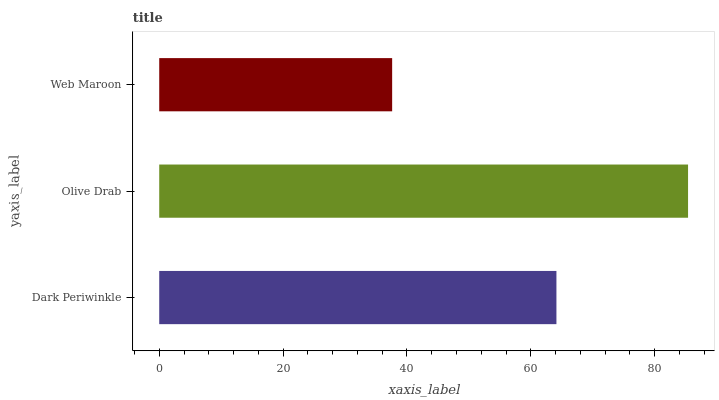Is Web Maroon the minimum?
Answer yes or no. Yes. Is Olive Drab the maximum?
Answer yes or no. Yes. Is Olive Drab the minimum?
Answer yes or no. No. Is Web Maroon the maximum?
Answer yes or no. No. Is Olive Drab greater than Web Maroon?
Answer yes or no. Yes. Is Web Maroon less than Olive Drab?
Answer yes or no. Yes. Is Web Maroon greater than Olive Drab?
Answer yes or no. No. Is Olive Drab less than Web Maroon?
Answer yes or no. No. Is Dark Periwinkle the high median?
Answer yes or no. Yes. Is Dark Periwinkle the low median?
Answer yes or no. Yes. Is Web Maroon the high median?
Answer yes or no. No. Is Olive Drab the low median?
Answer yes or no. No. 